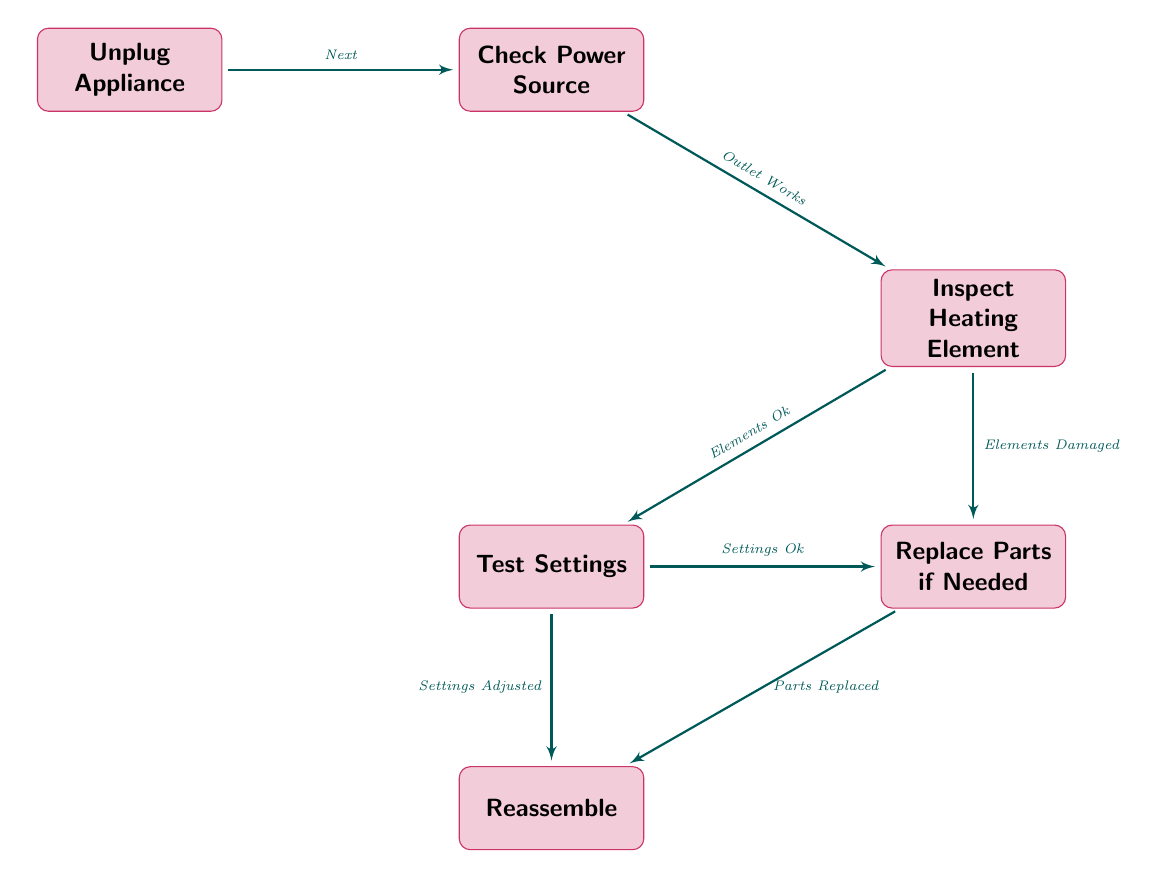What is the first step in troubleshooting the toaster? The diagram starts with the first node labeled "Unplug Appliance," which indicates that unplugging the appliance is the first step in the troubleshooting process for safety reasons.
Answer: Unplug Appliance How many nodes are present in the flow chart? By counting the distinct labeled blocks in the diagram, there are six nodes (Unplug Appliance, Check Power Source, Inspect Heating Element, Test Settings, Replace Parts if Needed, Reassemble).
Answer: Six What does the node "Check Power Source" lead to? The node "Check Power Source" has two possible paths: it leads to "Inspect Heating Element" if the "Outlet Works." If the outlet does not work, this step cannot progress further, indicating it is a critical step in determining the next actions. Therefore, it leads to "Inspect Heating Element."
Answer: Inspect Heating Element If the heating elements are damaged, what is the subsequent step? If the assessment of the heating elements reveals damage, the flow chart indicates a direct path to "Replace Parts if Needed," stipulating that addressing damage requires replacement before reassembly.
Answer: Replace Parts if Needed What node follows the "Test Settings"? According to the flow chart, "Test Settings" can branch out into two outcomes: if the settings are adjusted correctly, it leads to "Reassemble." This indicates proper function based on the test results that confirm settings correctness leads to the reassembly of the toaster.
Answer: Reassemble What should be done if parts are replaced? The diagram specifies that after replacing damaged or non-functional parts, the next step is to "Reassemble," meaning you need to put the toaster back together once the necessary replacements are made.
Answer: Reassemble What do you check after confirming the power source works? After confirming the power source works, the next node to check is "Inspect Heating Element," indicating that power validation allows further inspection of internal components essential for the toaster's function.
Answer: Inspect Heating Element If the settings are adjusted properly, what is the next action? The flow chart specifies that if the settings are correctly adjusted, it leads directly to "Reassemble," confirming that proper adjustment of settings is a prerequisite for putting the toaster back together.
Answer: Reassemble 